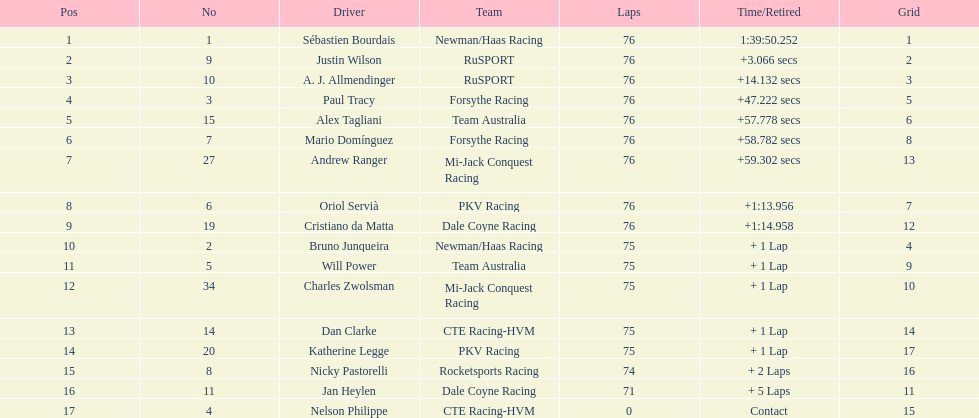What is the total point difference between the driver who received the most points and the driver who received the least? 30. 